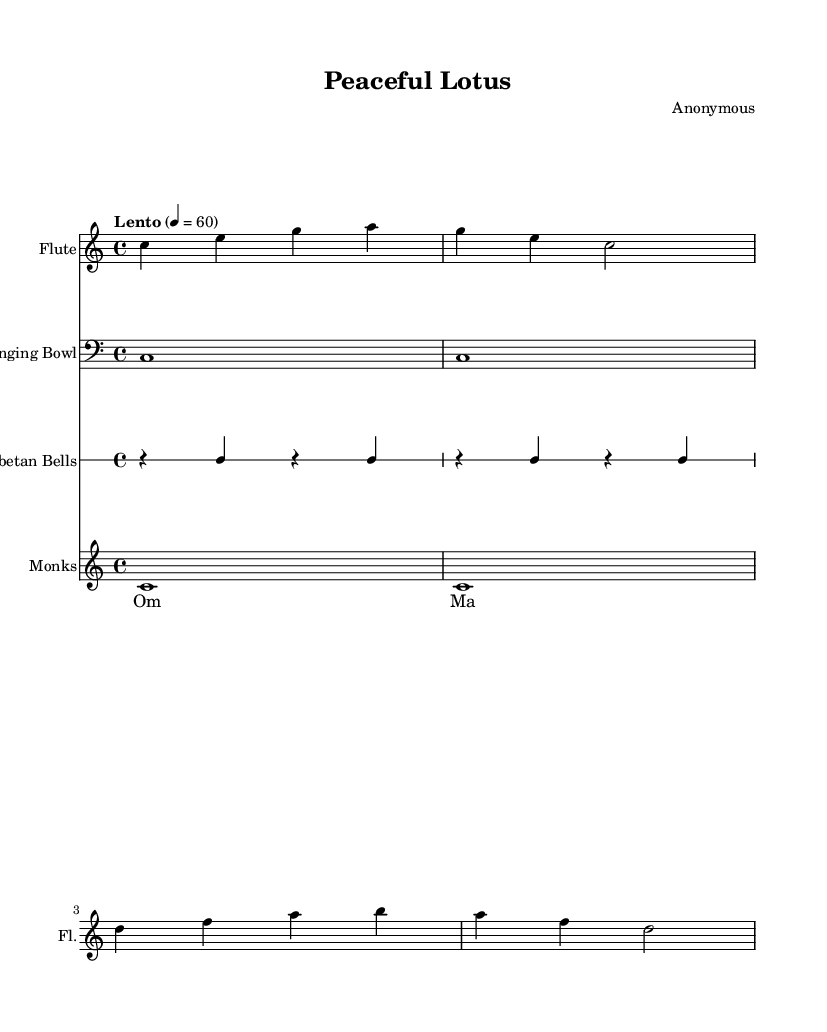What is the key signature of this music? The key signature is C major, which is indicated by the absence of sharps or flats at the beginning of the staff.
Answer: C major What is the time signature of this music? The time signature is 4/4, shown at the start of the score. This means there are four beats per measure.
Answer: 4/4 What tempo marking is indicated in the score? The tempo marking is "Lento," which is notated above the staff and indicates a slow tempo. The specific beats per minute is also indicated as 60.
Answer: Lento How many measures are in the flute part? The flute part has two measures, as indicated by the bar lines separating the musical phrases.
Answer: 2 What chant is sung by the monks? The chant consists of the repeated phrase "Om Mani Padme Hum," which is explicitly written in the lyric section for the monks.
Answer: Om Mani Padme Hum What is the dynamic of the singing bowl part? The singing bowl part does not have an indicated dynamic marking, which often implies a soft or sustaining sound throughout.
Answer: None indicated How many times is the chant repeated in the score? The chant "Om Mani Padme Hum" is repeated twice, as shown by its notation under the lyrics for the monks.
Answer: 2 times 